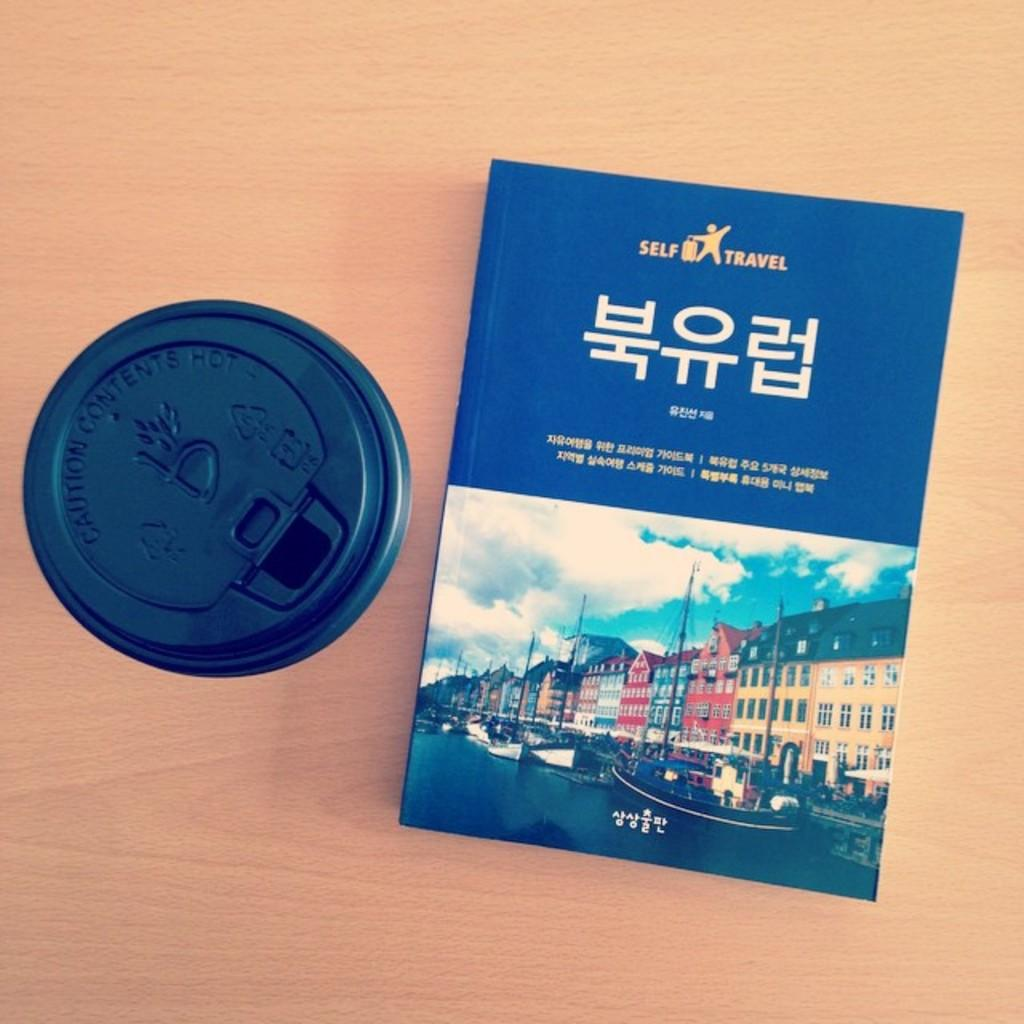<image>
Give a short and clear explanation of the subsequent image. a self travel book written in korean with a cup of coffee sitting next to it. 